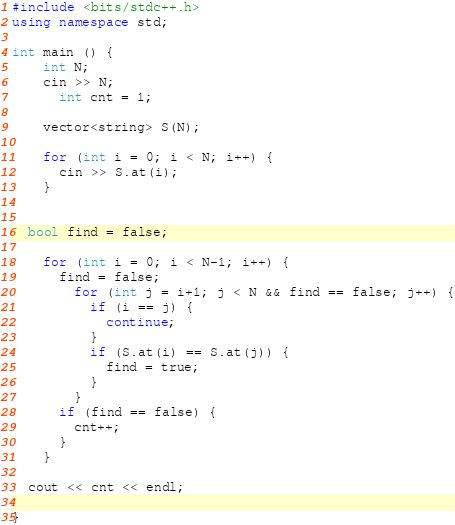Convert code to text. <code><loc_0><loc_0><loc_500><loc_500><_C++_>#include <bits/stdc++.h>
using namespace std;

int main () {
  	int N;
  	cin >> N;
      int cnt = 1;
  
	vector<string> S(N);
  
	for (int i = 0; i < N; i++) {
      cin >> S.at(i);
    }
 
  	
  bool find = false;
  
	for (int i = 0; i < N-1; i++) {
      find = false;
		for (int j = i+1; j < N && find == false; j++) {
          if (i == j) {
            continue;
          }
          if (S.at(i) == S.at(j)) {
            find = true;
          }
	    }
      if (find == false) {
        cnt++;
      }
    }
  
  cout << cnt << endl;

}</code> 